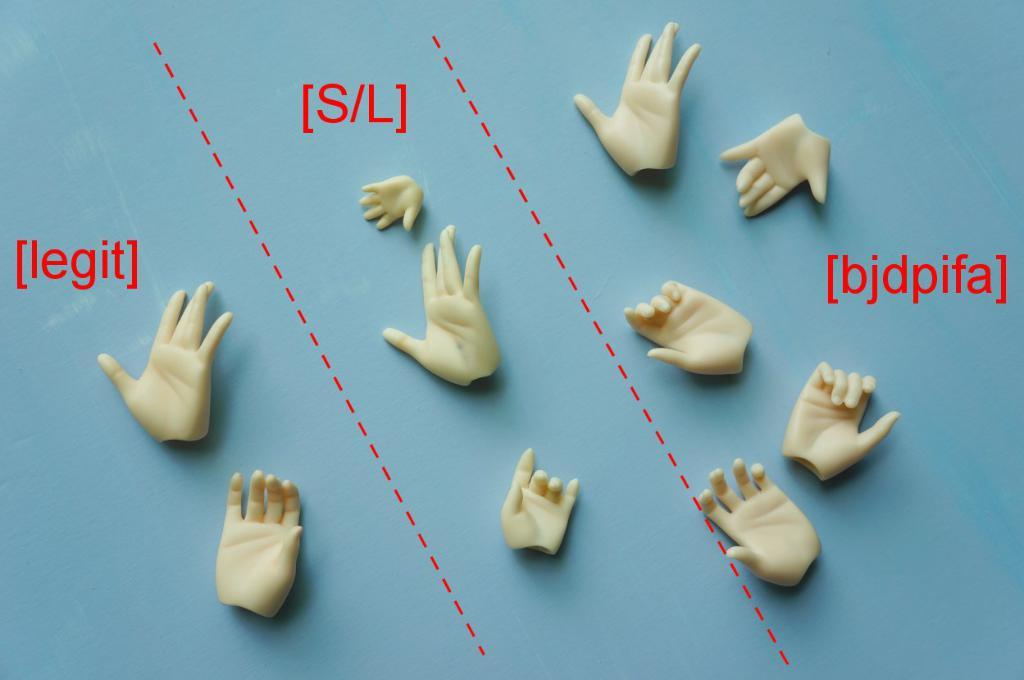What is the main subject of the image? The main subject of the image is a group of hand figurines. Can you describe the hand figurines in the image? Unfortunately, the image does not provide enough detail to describe the hand figurines. How many hand figurines are in the image? The number of hand figurines in the image cannot be determined from the provided facts. How does the group of hand figurines show their excitement in the image? The image does not depict any emotions or expressions on the hand figurines, so it cannot be determined how they might show excitement. 